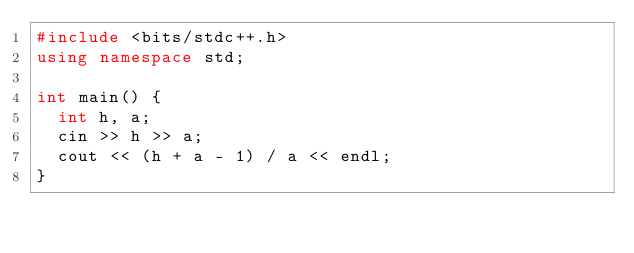<code> <loc_0><loc_0><loc_500><loc_500><_C++_>#include <bits/stdc++.h>
using namespace std;

int main() {
  int h, a;
  cin >> h >> a;
  cout << (h + a - 1) / a << endl;
}</code> 